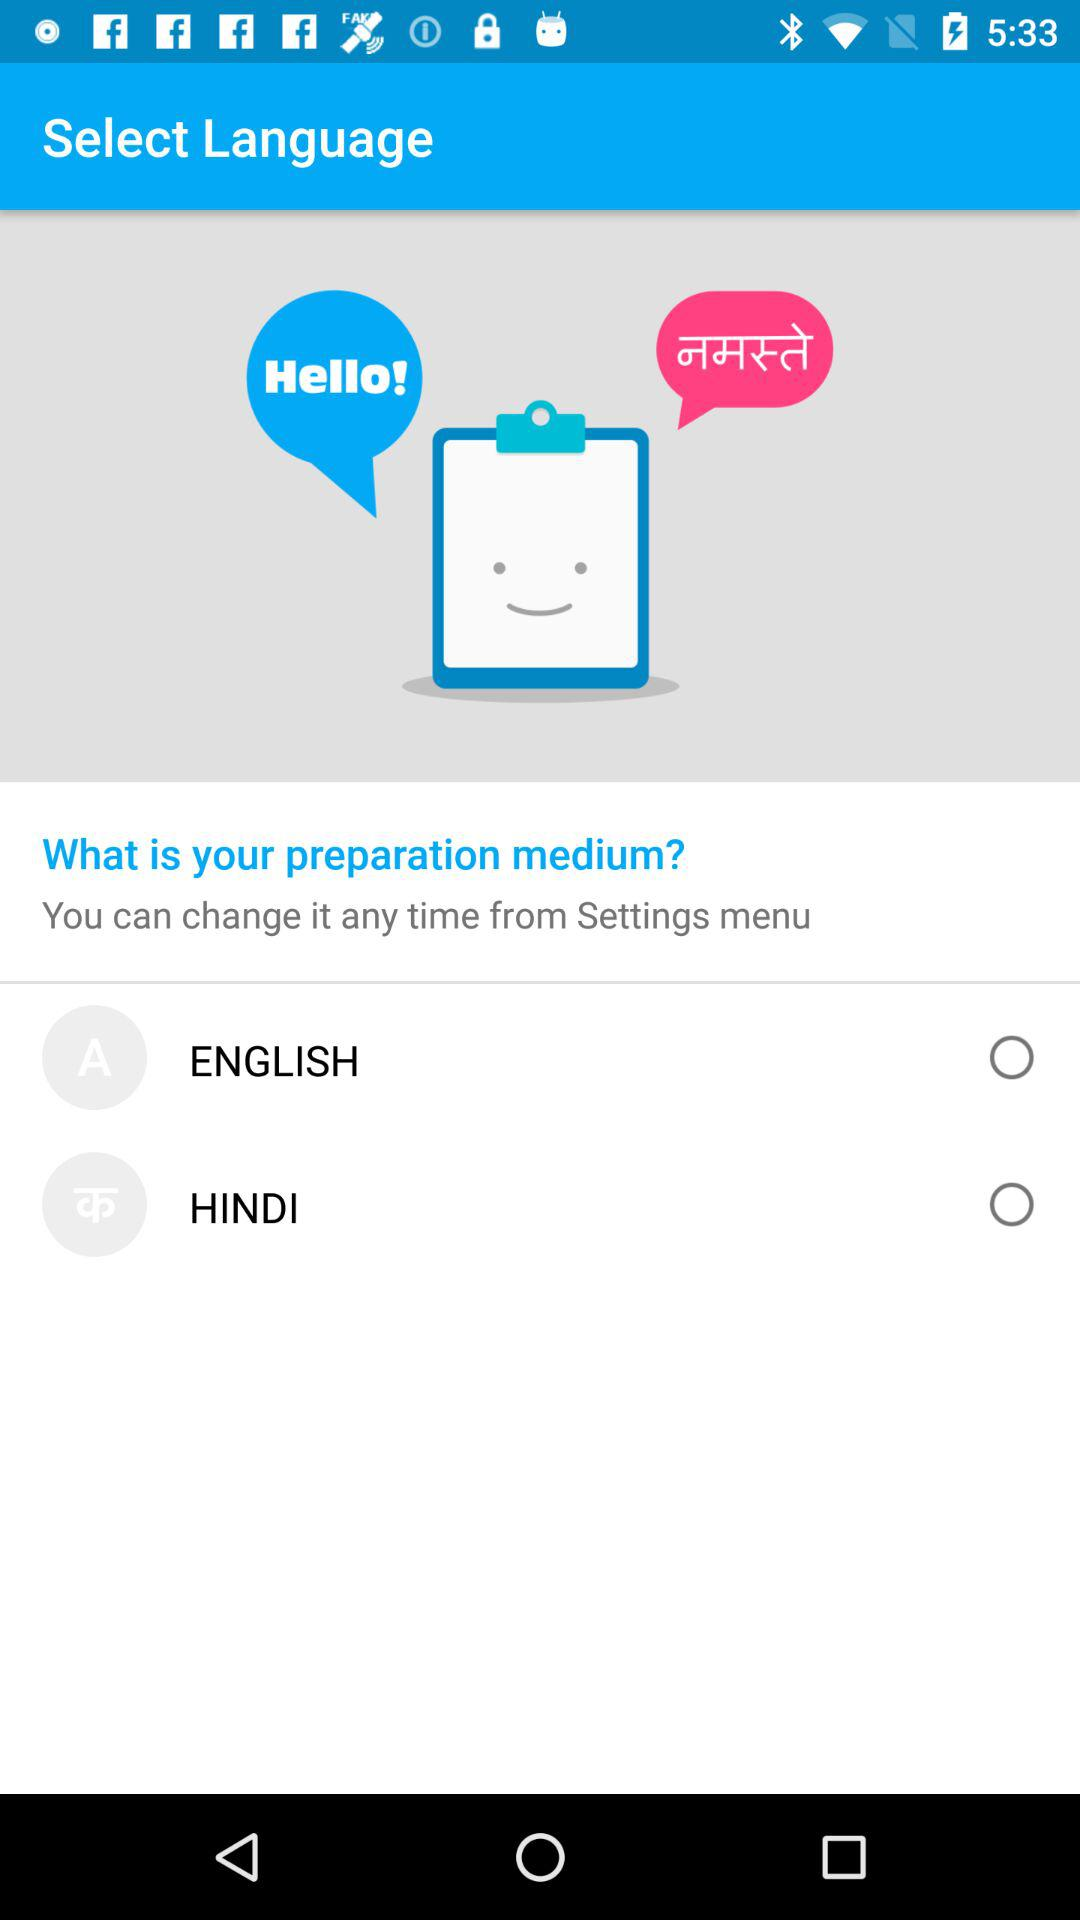What are the options for "What is your preparation medium?"? The options are "ENGLISH" and "HINDI". 